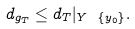<formula> <loc_0><loc_0><loc_500><loc_500>d _ { g _ { T } } \leq d _ { T } | _ { Y \ \{ y _ { 0 } \} } .</formula> 